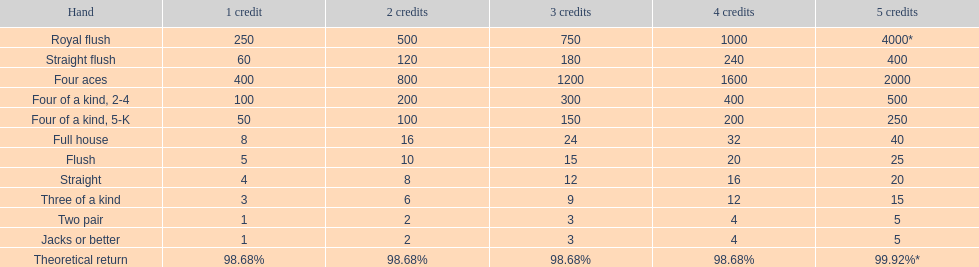I'm looking to parse the entire table for insights. Could you assist me with that? {'header': ['Hand', '1 credit', '2 credits', '3 credits', '4 credits', '5 credits'], 'rows': [['Royal flush', '250', '500', '750', '1000', '4000*'], ['Straight flush', '60', '120', '180', '240', '400'], ['Four aces', '400', '800', '1200', '1600', '2000'], ['Four of a kind, 2-4', '100', '200', '300', '400', '500'], ['Four of a kind, 5-K', '50', '100', '150', '200', '250'], ['Full house', '8', '16', '24', '32', '40'], ['Flush', '5', '10', '15', '20', '25'], ['Straight', '4', '8', '12', '16', '20'], ['Three of a kind', '3', '6', '9', '12', '15'], ['Two pair', '1', '2', '3', '4', '5'], ['Jacks or better', '1', '2', '3', '4', '5'], ['Theoretical return', '98.68%', '98.68%', '98.68%', '98.68%', '99.92%*']]} Does a 2 credit full house have the same value as a 5 credit trio? No. 